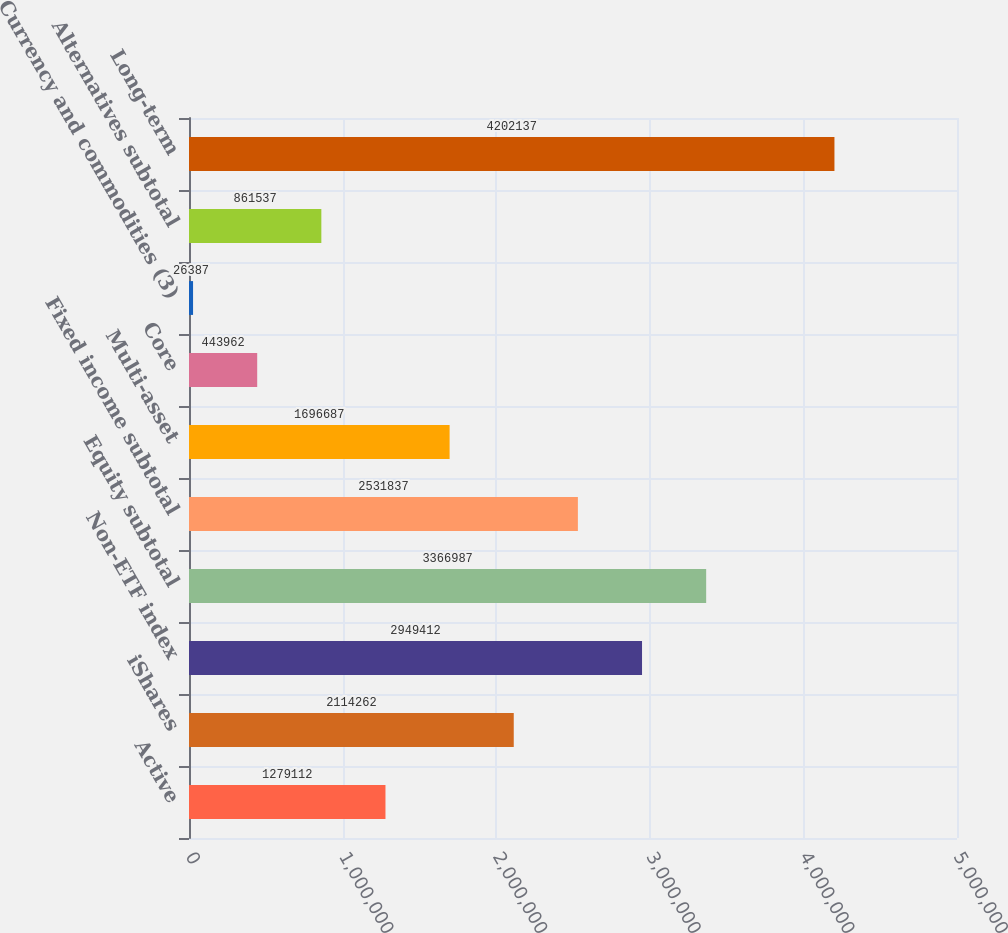Convert chart to OTSL. <chart><loc_0><loc_0><loc_500><loc_500><bar_chart><fcel>Active<fcel>iShares<fcel>Non-ETF index<fcel>Equity subtotal<fcel>Fixed income subtotal<fcel>Multi-asset<fcel>Core<fcel>Currency and commodities (3)<fcel>Alternatives subtotal<fcel>Long-term<nl><fcel>1.27911e+06<fcel>2.11426e+06<fcel>2.94941e+06<fcel>3.36699e+06<fcel>2.53184e+06<fcel>1.69669e+06<fcel>443962<fcel>26387<fcel>861537<fcel>4.20214e+06<nl></chart> 